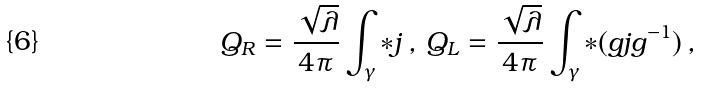Convert formula to latex. <formula><loc_0><loc_0><loc_500><loc_500>Q _ { R } = \frac { \sqrt { \lambda } } { 4 \pi } \int _ { \gamma } \ast j \, , \, Q _ { L } = \frac { \sqrt { \lambda } } { 4 \pi } \int _ { \gamma } \ast ( g j g ^ { - 1 } ) \, ,</formula> 